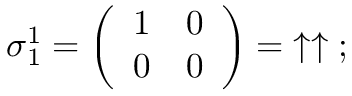<formula> <loc_0><loc_0><loc_500><loc_500>{ \sigma } _ { 1 } ^ { 1 } = { \left ( \begin{array} { l l } { 1 } & { 0 } \\ { 0 } & { 0 } \end{array} \right ) } = \, \uparrow \uparrow \, ;</formula> 